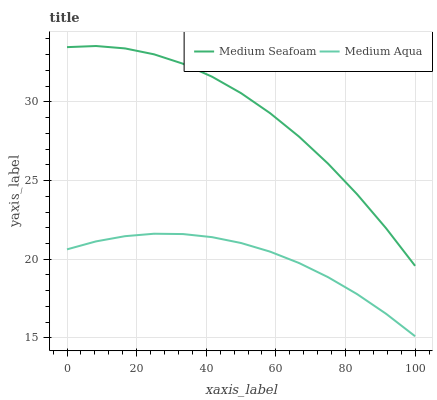Does Medium Aqua have the minimum area under the curve?
Answer yes or no. Yes. Does Medium Seafoam have the maximum area under the curve?
Answer yes or no. Yes. Does Medium Seafoam have the minimum area under the curve?
Answer yes or no. No. Is Medium Aqua the smoothest?
Answer yes or no. Yes. Is Medium Seafoam the roughest?
Answer yes or no. Yes. Is Medium Seafoam the smoothest?
Answer yes or no. No. Does Medium Aqua have the lowest value?
Answer yes or no. Yes. Does Medium Seafoam have the lowest value?
Answer yes or no. No. Does Medium Seafoam have the highest value?
Answer yes or no. Yes. Is Medium Aqua less than Medium Seafoam?
Answer yes or no. Yes. Is Medium Seafoam greater than Medium Aqua?
Answer yes or no. Yes. Does Medium Aqua intersect Medium Seafoam?
Answer yes or no. No. 